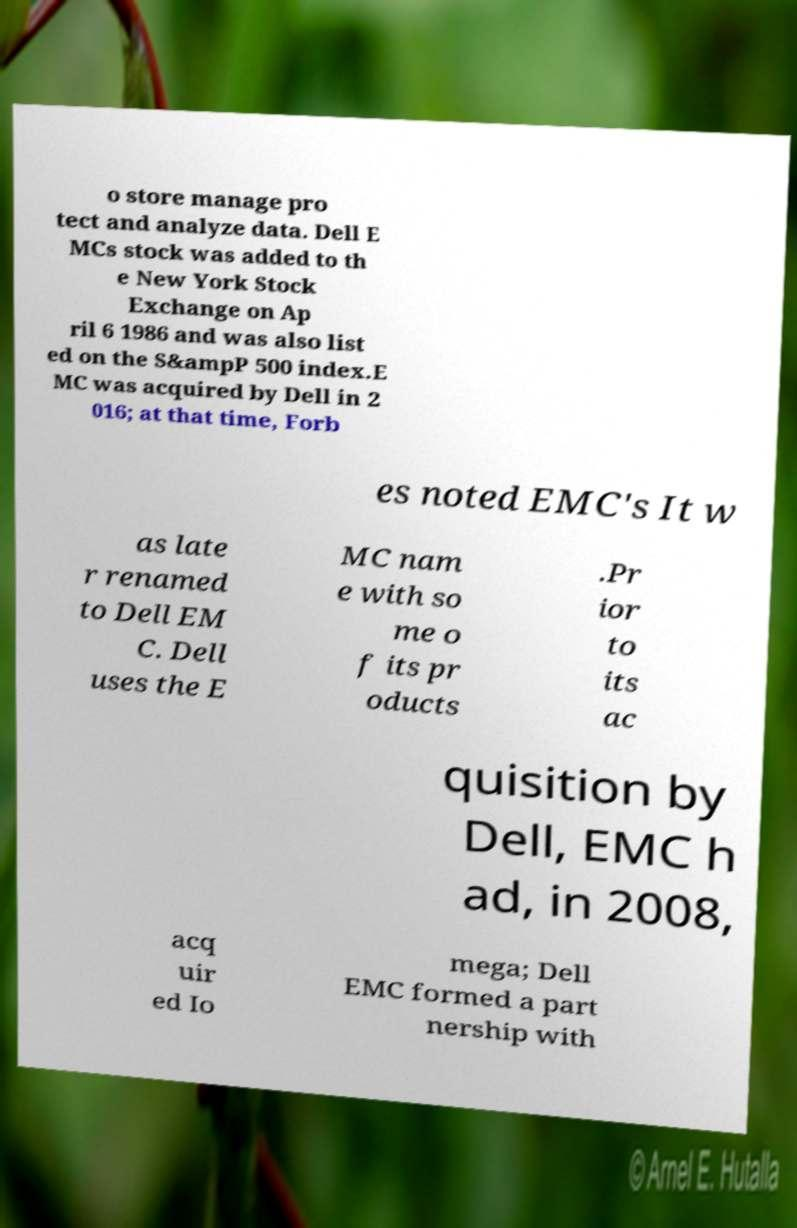Could you assist in decoding the text presented in this image and type it out clearly? o store manage pro tect and analyze data. Dell E MCs stock was added to th e New York Stock Exchange on Ap ril 6 1986 and was also list ed on the S&ampP 500 index.E MC was acquired by Dell in 2 016; at that time, Forb es noted EMC's It w as late r renamed to Dell EM C. Dell uses the E MC nam e with so me o f its pr oducts .Pr ior to its ac quisition by Dell, EMC h ad, in 2008, acq uir ed Io mega; Dell EMC formed a part nership with 